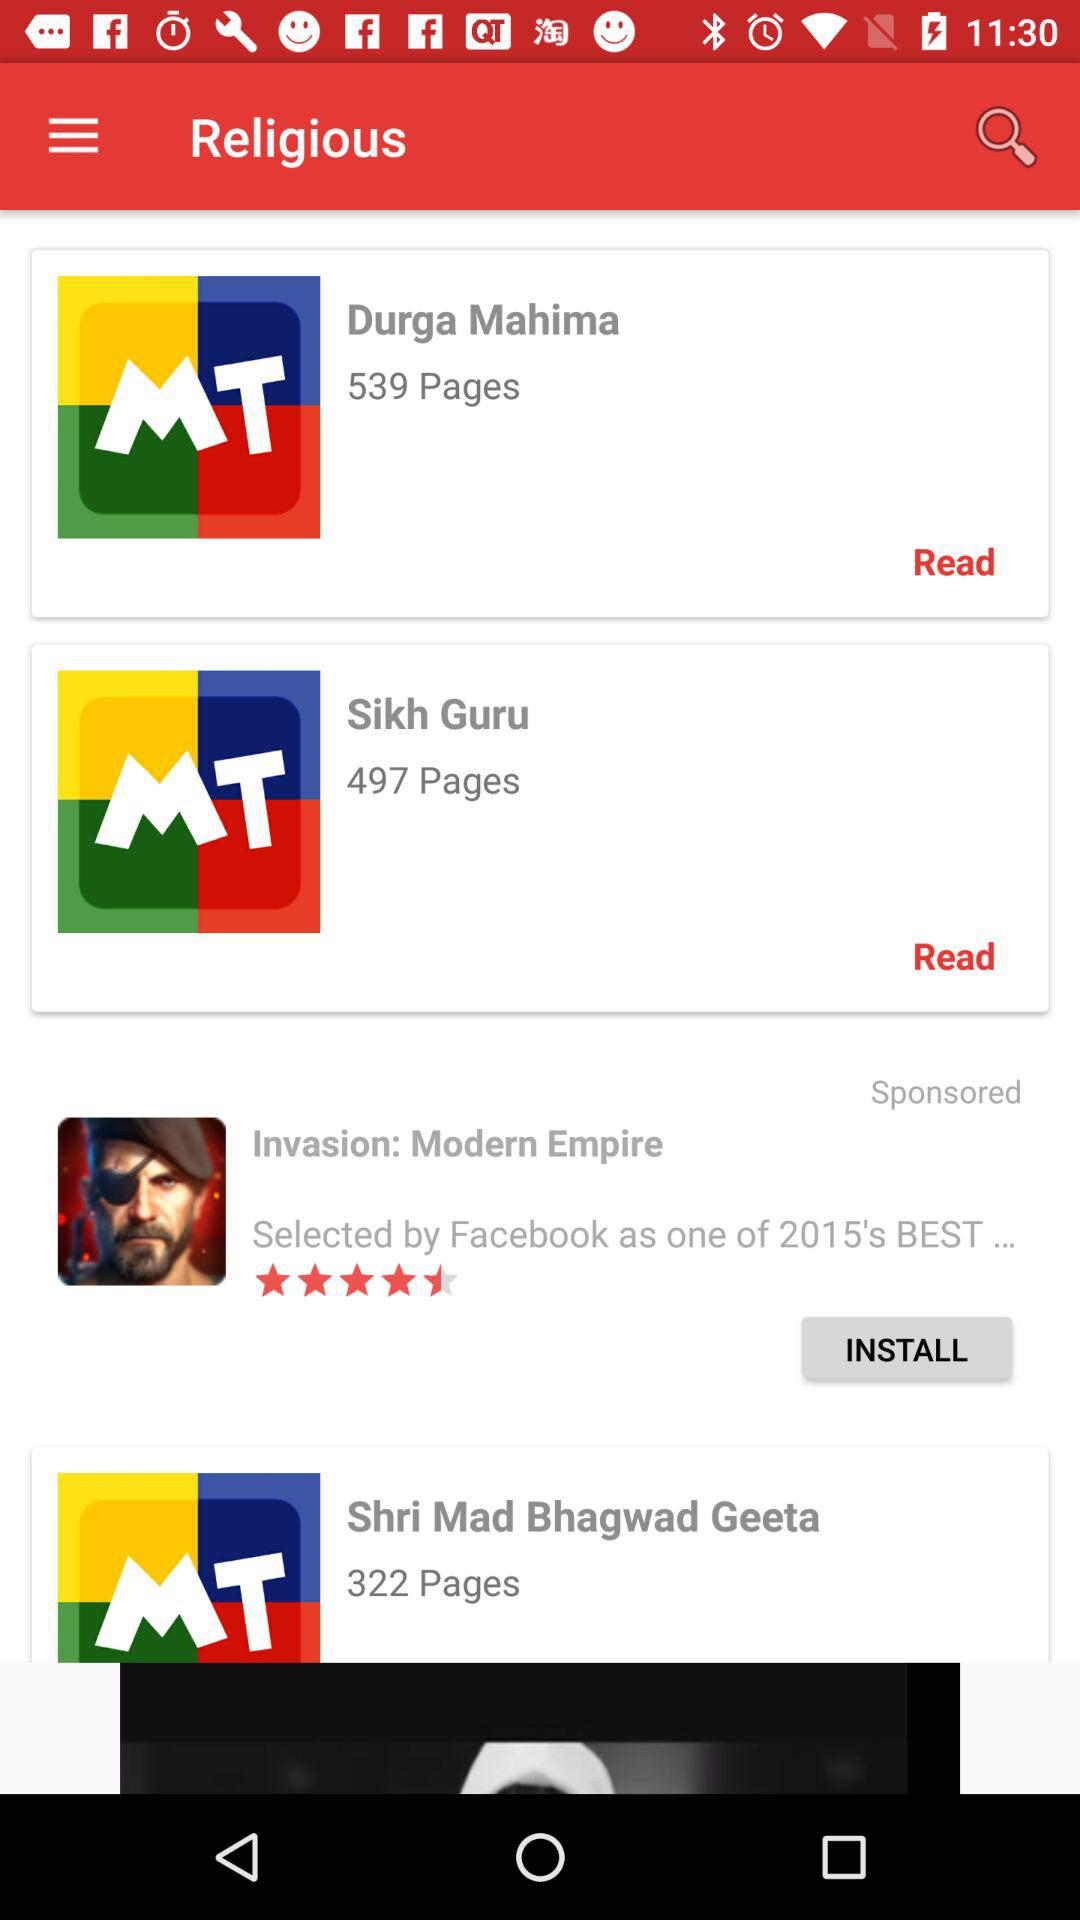How many books in total are there?
Answer the question using a single word or phrase. 3 